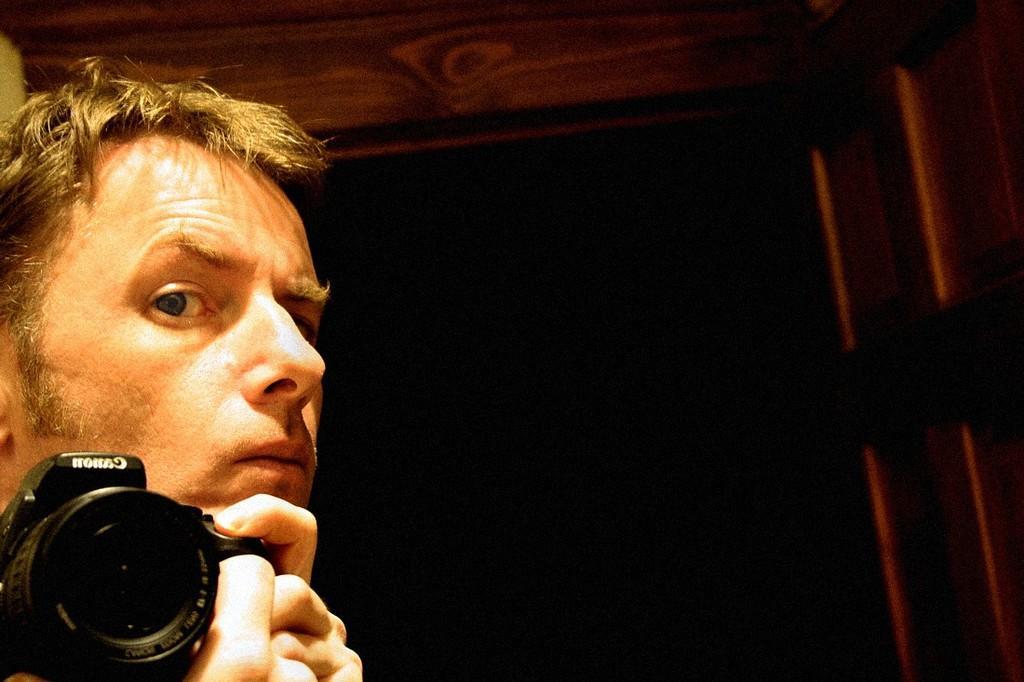Could you give a brief overview of what you see in this image? In this picture we can able to see a person is holding a camera. 